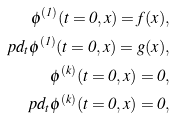<formula> <loc_0><loc_0><loc_500><loc_500>\phi ^ { ( 1 ) } ( t = 0 , x ) = f ( x ) , \\ \ p d _ { t } \phi ^ { ( 1 ) } ( t = 0 , x ) = g ( x ) , \\ \phi ^ { ( k ) } ( t = 0 , x ) = 0 , \\ \ p d _ { t } \phi ^ { ( k ) } ( t = 0 , x ) = 0 ,</formula> 